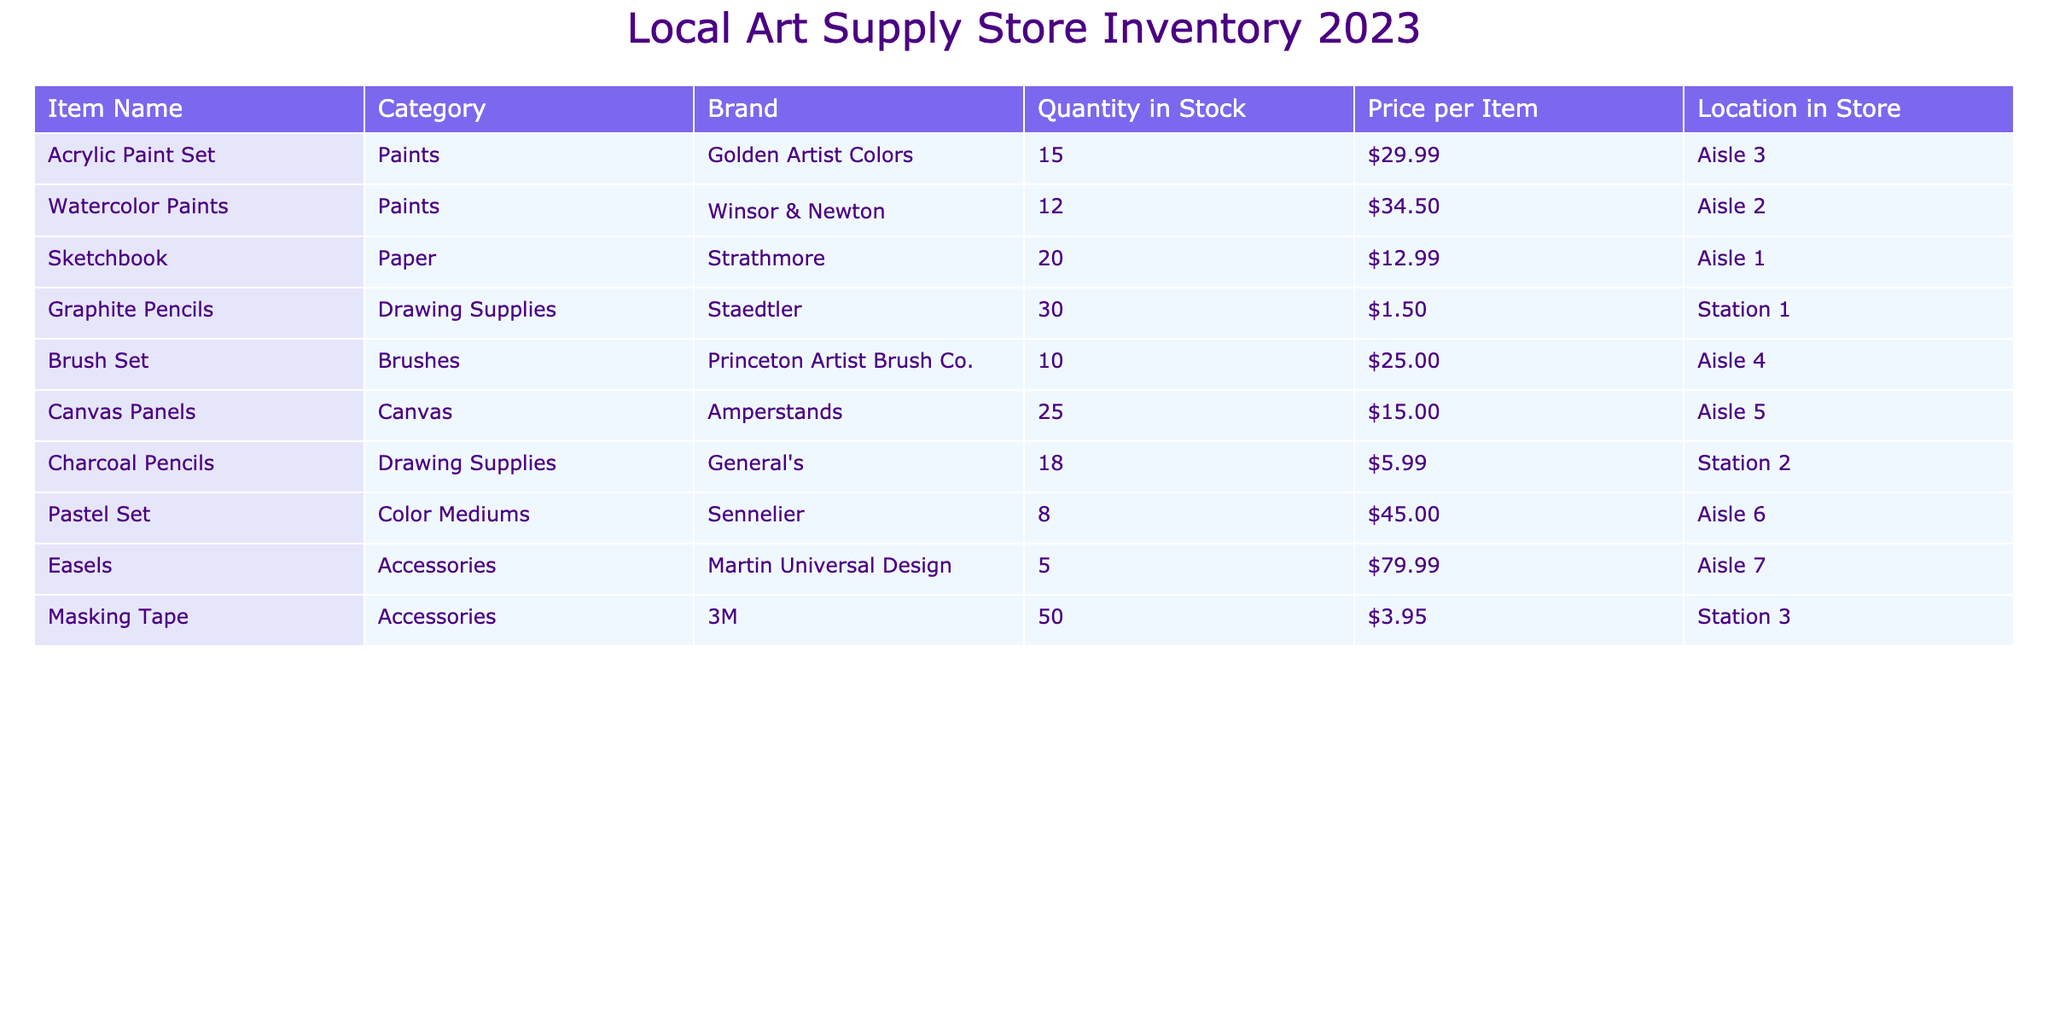What is the total quantity of brushes available in the store? There is one brush item listed in the inventory: the Brush Set, which has a quantity of 10 in stock. Therefore, the total quantity of brushes available is 10.
Answer: 10 What is the price of the Watercolor Paints? By locating the Watercolor Paints in the table, it is found that they are priced at $34.50.
Answer: $34.50 Are there more than 20 sketchbooks in stock? The table shows that there are 20 sketchbooks in stock. Hence, the statement is false because there are not more than 20 sketchbooks.
Answer: No What is the average price of drawing supplies? The drawing supplies are: Graphite Pencils at $1.50 and Charcoal Pencils at $5.99. Summing these prices gives $1.50 + $5.99 = $7.49. Then, dividing by the number of items (2), the average price is $7.49 / 2 = $3.745.
Answer: $3.75 How many items are located in Aisle 2? The table lists three categories in Aisle 2: Watercolor Paints, Sketchbook, and Masking Tape. Counting these gives a total of 2 items (Watercolor Paints, 12 in stock and Sketchbook, 20 in stock). So there are 2 distinct items.
Answer: 2 What is the total stock of acrylic paint sets and pastel sets combined? The quantity of Acrylic Paint Sets is 15 and the quantity of Pastel Sets is 8. Adding these gives 15 + 8 = 23.
Answer: 23 Is the price of all accessories over $50? There are two accessory items: Easels priced at $79.99 and Masking Tape priced at $3.95. Since Masking Tape is below $50, the statement is false.
Answer: No Which item has the highest quantity in stock? By reviewing the quantities listed: Acrylic Paint Set (15), Watercolor Paints (12), Sketchbook (20), Graphite Pencils (30), Brush Set (10), Canvas Panels (25), Charcoal Pencils (18), Pastel Set (8), Easels (5), and Masking Tape (50), we see that Masking Tape has the highest stock with 50 units.
Answer: Masking Tape 